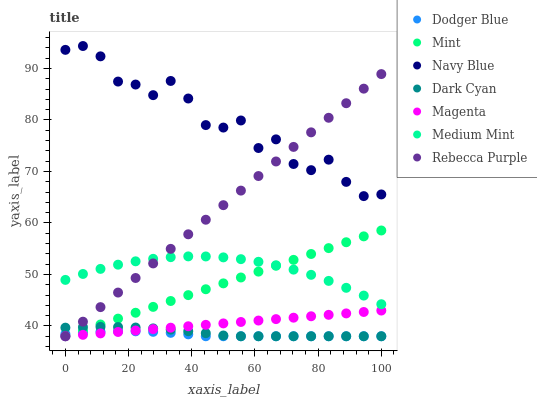Does Dodger Blue have the minimum area under the curve?
Answer yes or no. Yes. Does Navy Blue have the maximum area under the curve?
Answer yes or no. Yes. Does Navy Blue have the minimum area under the curve?
Answer yes or no. No. Does Dodger Blue have the maximum area under the curve?
Answer yes or no. No. Is Mint the smoothest?
Answer yes or no. Yes. Is Navy Blue the roughest?
Answer yes or no. Yes. Is Dodger Blue the smoothest?
Answer yes or no. No. Is Dodger Blue the roughest?
Answer yes or no. No. Does Dodger Blue have the lowest value?
Answer yes or no. Yes. Does Navy Blue have the lowest value?
Answer yes or no. No. Does Navy Blue have the highest value?
Answer yes or no. Yes. Does Dodger Blue have the highest value?
Answer yes or no. No. Is Mint less than Navy Blue?
Answer yes or no. Yes. Is Medium Mint greater than Magenta?
Answer yes or no. Yes. Does Dark Cyan intersect Rebecca Purple?
Answer yes or no. Yes. Is Dark Cyan less than Rebecca Purple?
Answer yes or no. No. Is Dark Cyan greater than Rebecca Purple?
Answer yes or no. No. Does Mint intersect Navy Blue?
Answer yes or no. No. 